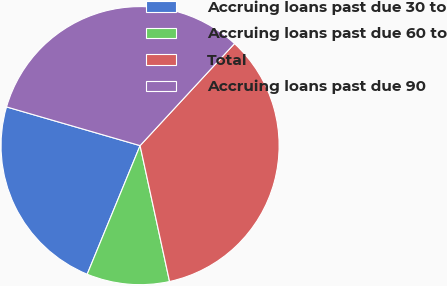Convert chart. <chart><loc_0><loc_0><loc_500><loc_500><pie_chart><fcel>Accruing loans past due 30 to<fcel>Accruing loans past due 60 to<fcel>Total<fcel>Accruing loans past due 90<nl><fcel>23.28%<fcel>9.61%<fcel>34.72%<fcel>32.39%<nl></chart> 